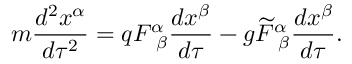<formula> <loc_0><loc_0><loc_500><loc_500>m \frac { d ^ { 2 } x ^ { \alpha } } { d \tau ^ { 2 } } = q F _ { \beta } ^ { \alpha } \frac { d x ^ { \beta } } { d \tau } - g \widetilde { F } _ { \beta } ^ { \alpha } \frac { d x ^ { \beta } } { d \tau } .</formula> 